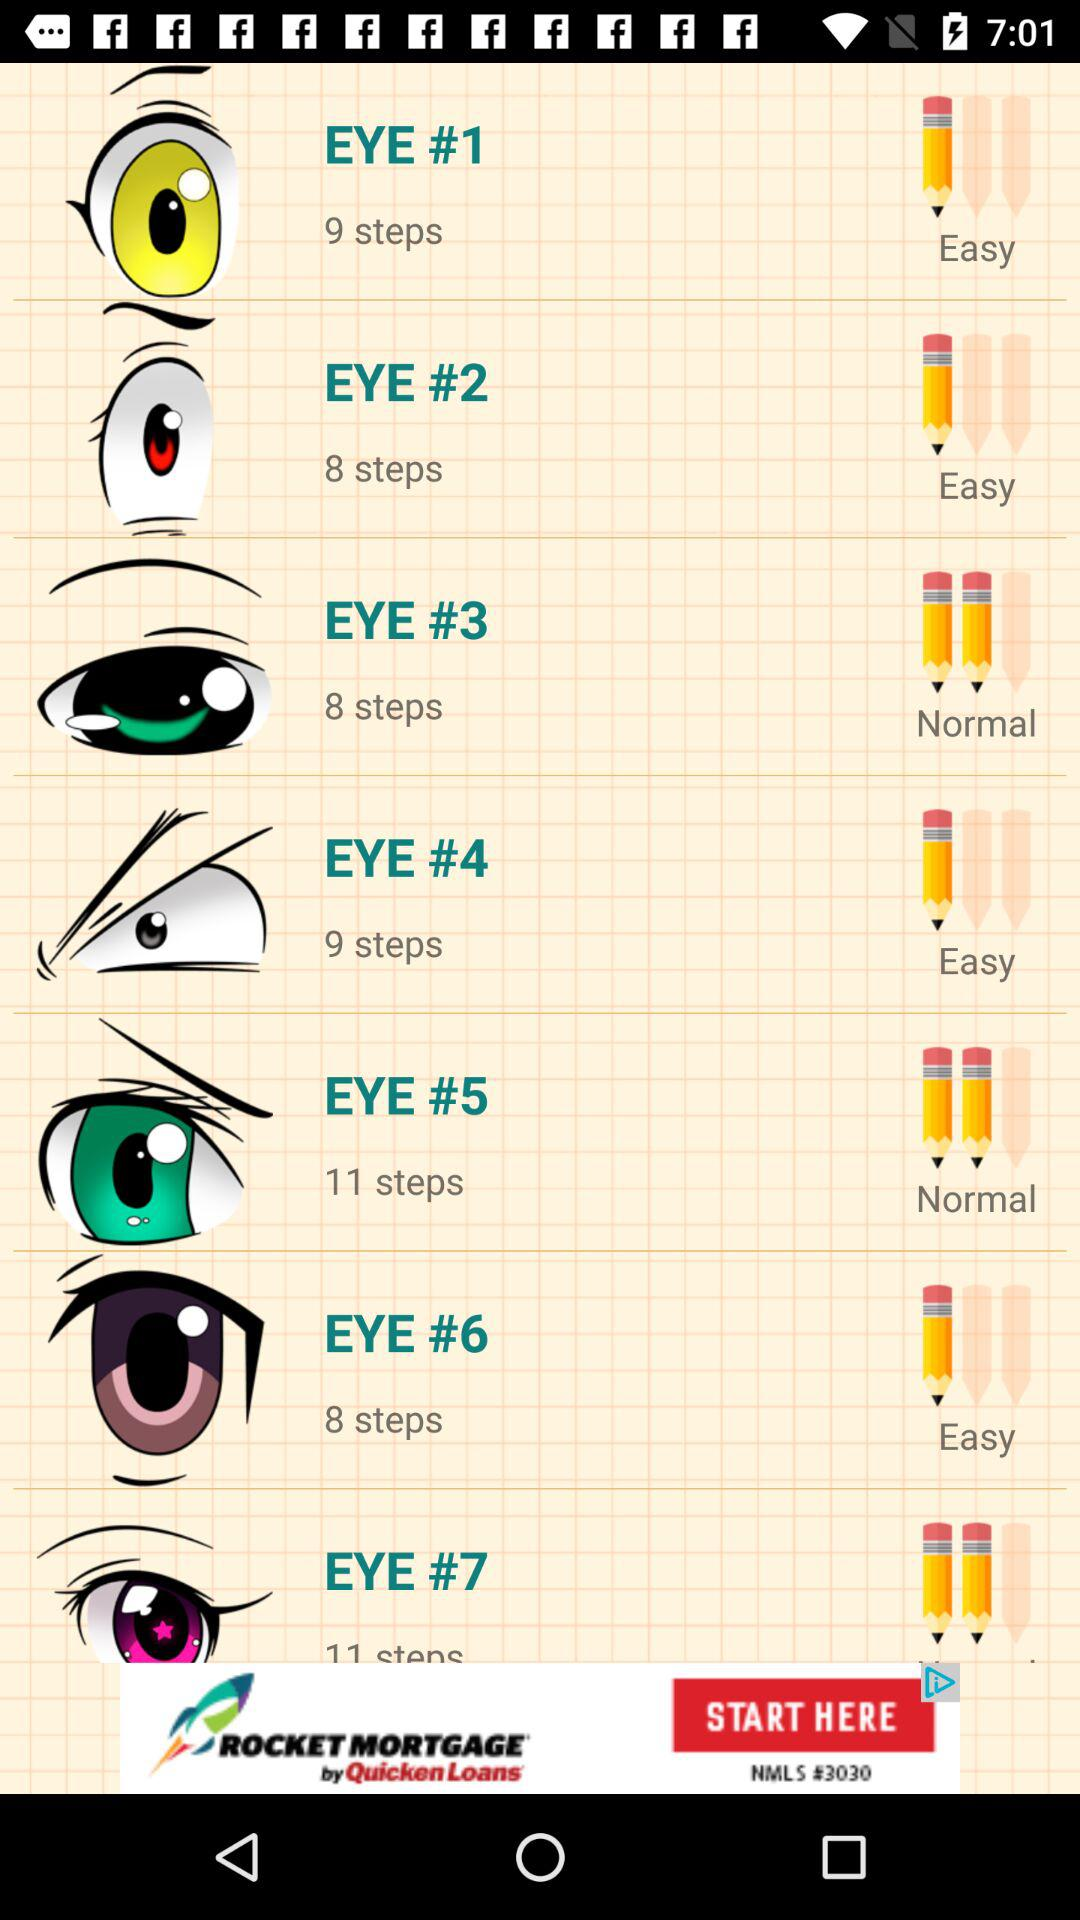How many eyes have a green pupil?
Answer the question using a single word or phrase. 1 